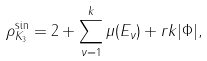Convert formula to latex. <formula><loc_0><loc_0><loc_500><loc_500>\rho _ { K _ { 3 } } ^ { \sin } = 2 + \sum _ { \nu = 1 } ^ { k } \mu ( E _ { \nu } ) + r k | \Phi | ,</formula> 